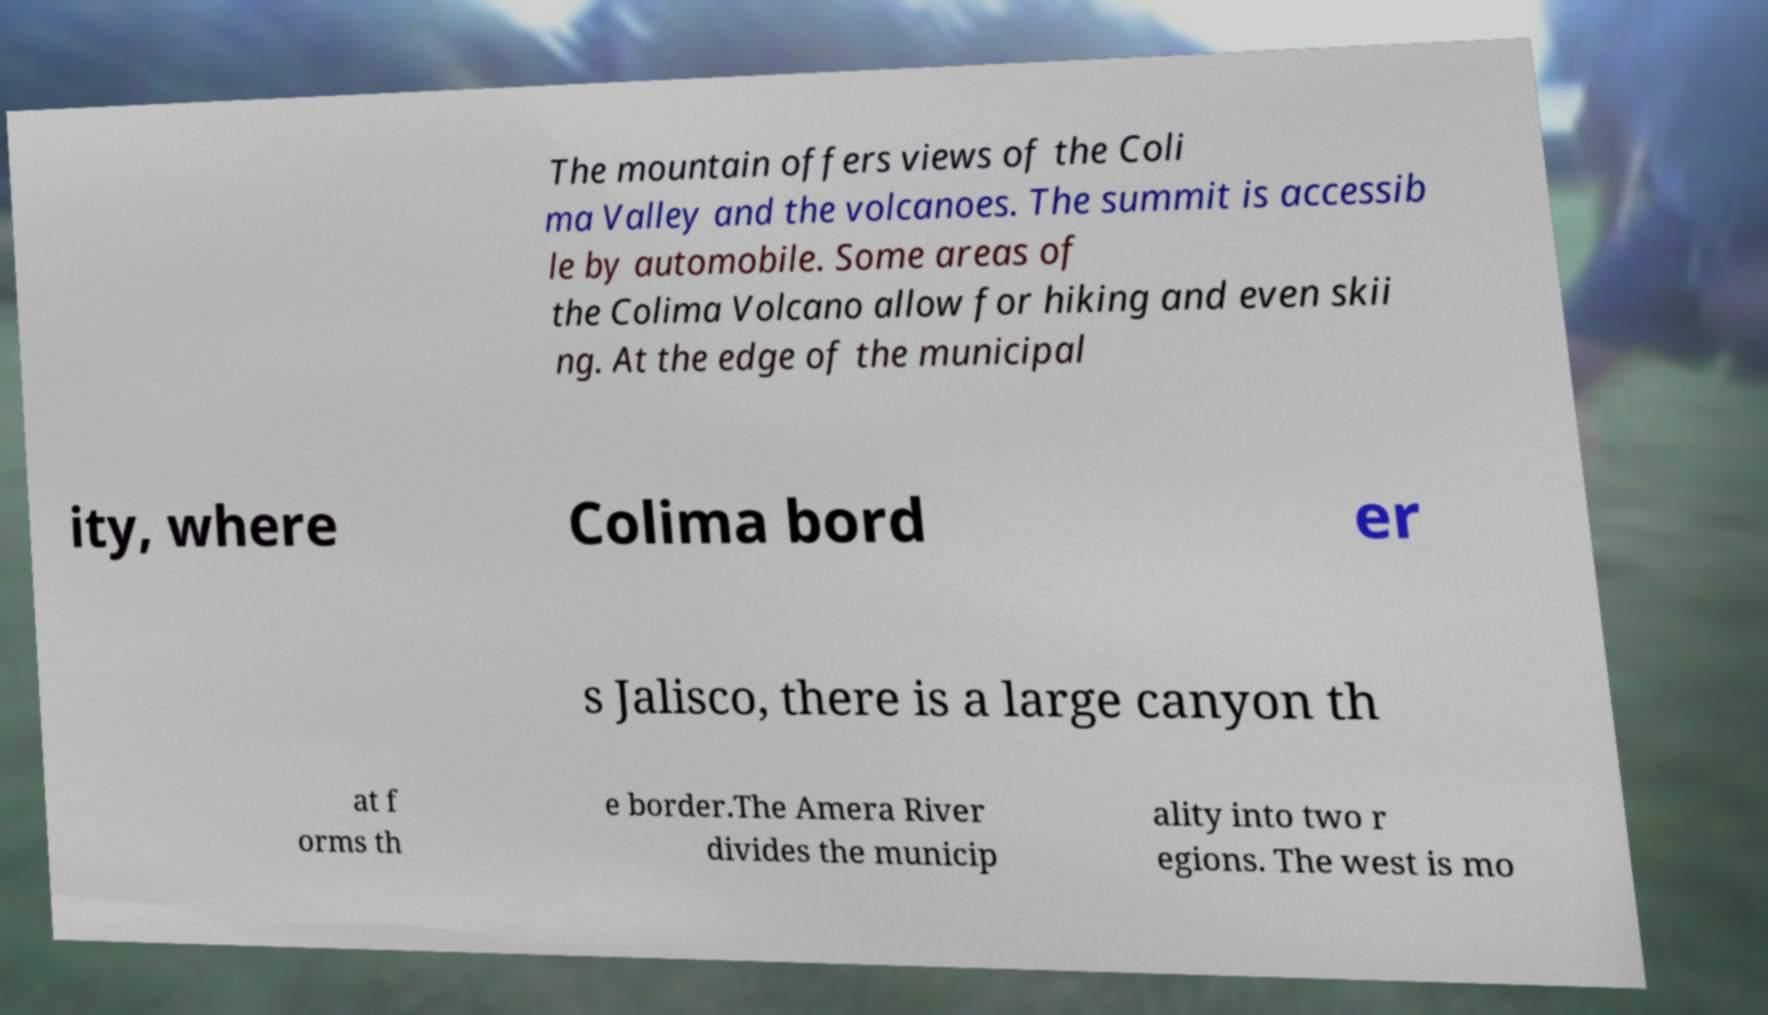What messages or text are displayed in this image? I need them in a readable, typed format. The mountain offers views of the Coli ma Valley and the volcanoes. The summit is accessib le by automobile. Some areas of the Colima Volcano allow for hiking and even skii ng. At the edge of the municipal ity, where Colima bord er s Jalisco, there is a large canyon th at f orms th e border.The Amera River divides the municip ality into two r egions. The west is mo 